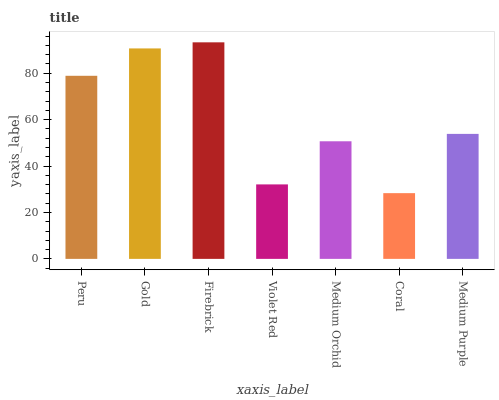Is Coral the minimum?
Answer yes or no. Yes. Is Firebrick the maximum?
Answer yes or no. Yes. Is Gold the minimum?
Answer yes or no. No. Is Gold the maximum?
Answer yes or no. No. Is Gold greater than Peru?
Answer yes or no. Yes. Is Peru less than Gold?
Answer yes or no. Yes. Is Peru greater than Gold?
Answer yes or no. No. Is Gold less than Peru?
Answer yes or no. No. Is Medium Purple the high median?
Answer yes or no. Yes. Is Medium Purple the low median?
Answer yes or no. Yes. Is Coral the high median?
Answer yes or no. No. Is Violet Red the low median?
Answer yes or no. No. 